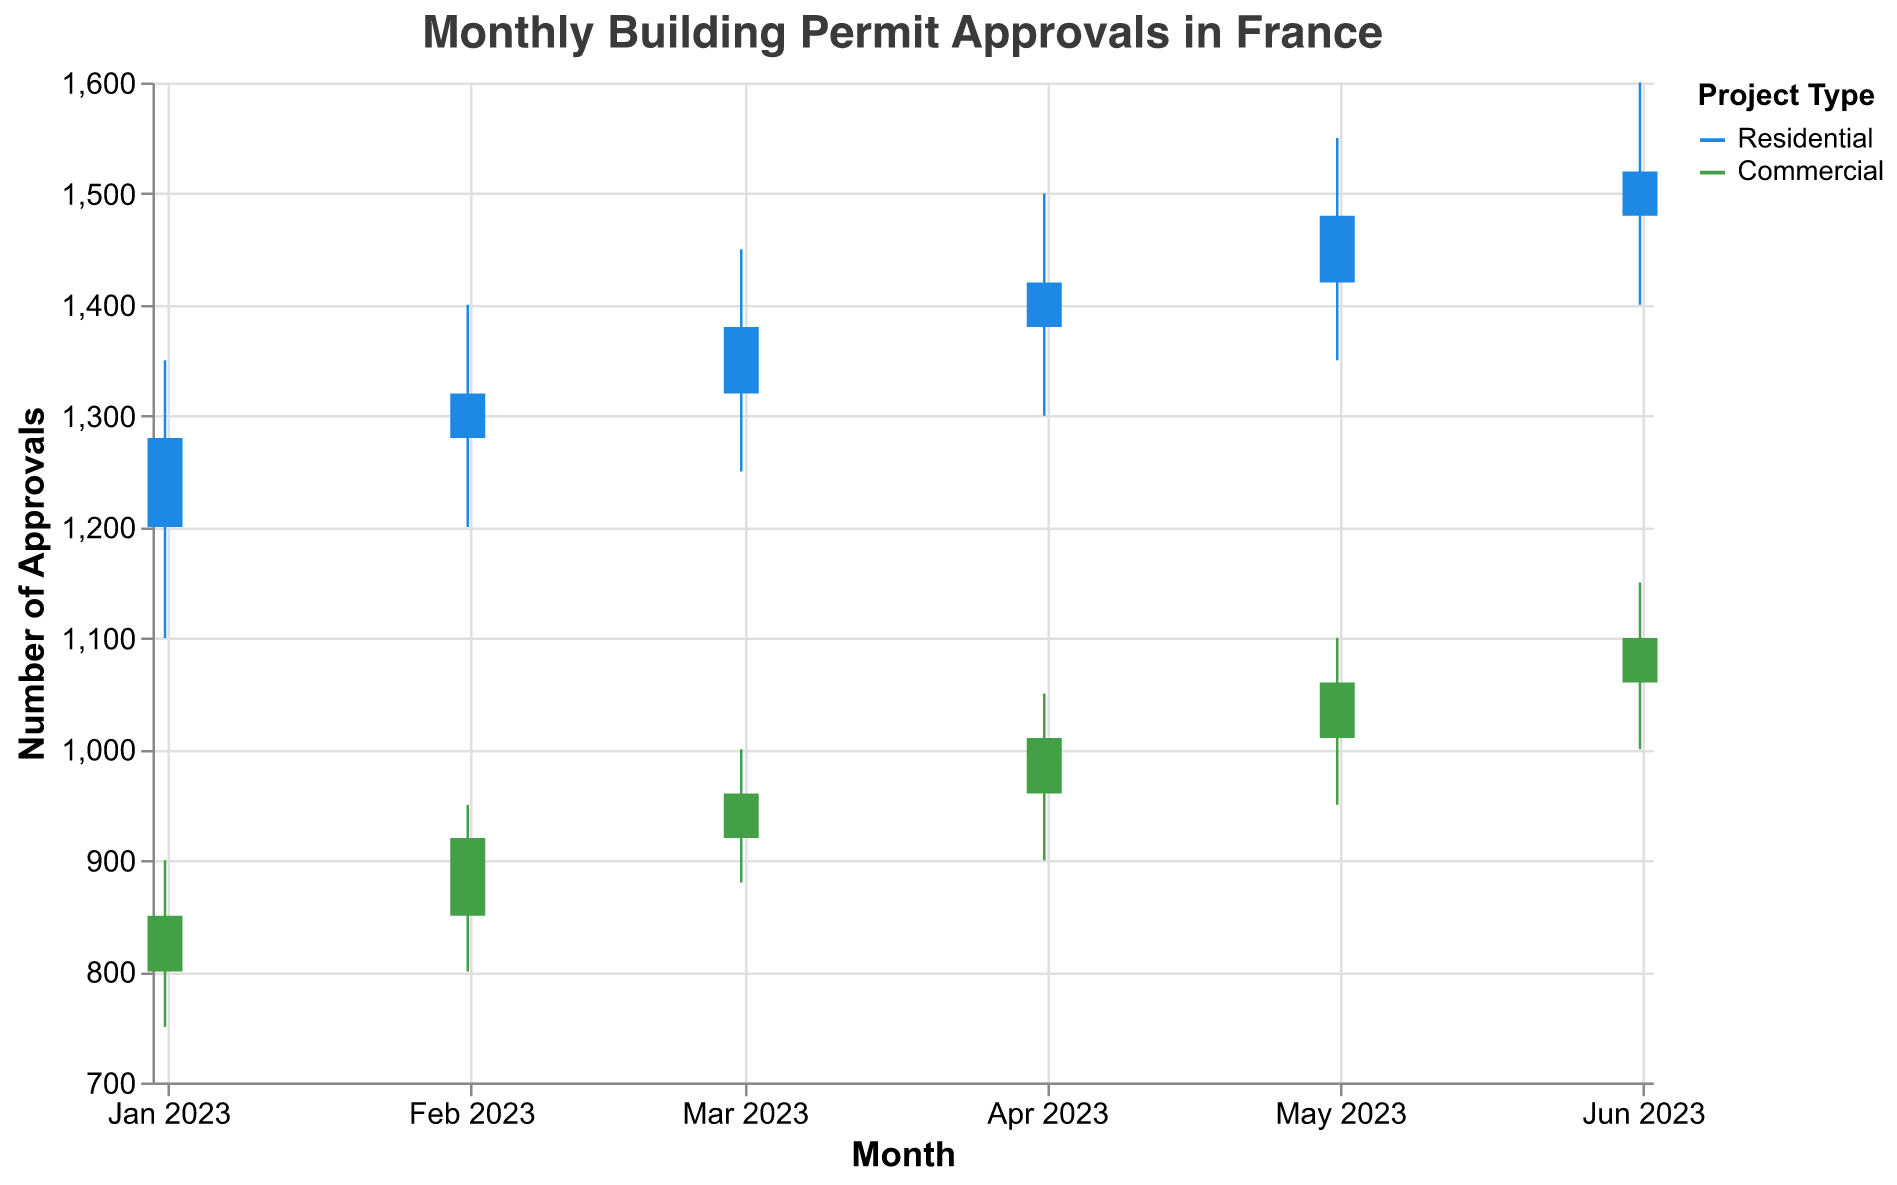What is the title of the chart? The title is prominently displayed at the top of the chart, which is "Monthly Building Permit Approvals in France"
Answer: Monthly Building Permit Approvals in France How does the number of residential permit approvals on March 2023 compare to January 2023? To compare, look at the 'Close' values for residential projects in January and March 2023. In January, it closes at 1280 and in March at 1380, indicating an increase
Answer: Higher in March Which month has the highest 'High' value for commercial project approvals? By checking the 'High' values for commercial projects across all months, we see that April has the highest 'High' value of 1050
Answer: April What color is used to represent residential projects? The color key indicates that residential projects are represented by a shade of blue
Answer: Blue How many months display data in this chart? By observing the x-axis that represents months, we see data points for January to June, totaling six months
Answer: Six What is the 'Low' value for commercial permits in May 2023? The 'Low' value for commercial permits in May 2023 is indicated as 950 in the dataset
Answer: 950 What is the difference between the 'Open' and 'Close' values for residential projects in February 2023? To find the difference, subtract the 'Close' value (1320) from the 'Open' value (1280). This results in a difference of 40
Answer: 40 How does the trend of 'High' values for residential projects move from January to June 2023? By tracking the 'High' values over the months, we observe a consistent upward trend from 1350 in January to 1600 in June
Answer: Increasing trend Which project type shows a greater increase from 'Open' to 'Close' values on June 2023? For June 2023, the residential project's increase is 1520 - 1480 = 40, while the commercial project's increase is 1100 - 1060 = 40. Both increases are the same
Answer: Both are equal Which project type had a higher range of approval values (difference between 'High' and 'Low') in April 2023? Calculate the range for each project. For residential: 1500 - 1300 = 200. For commercial: 1050 - 900 = 150. Residential has a higher range
Answer: Residential 